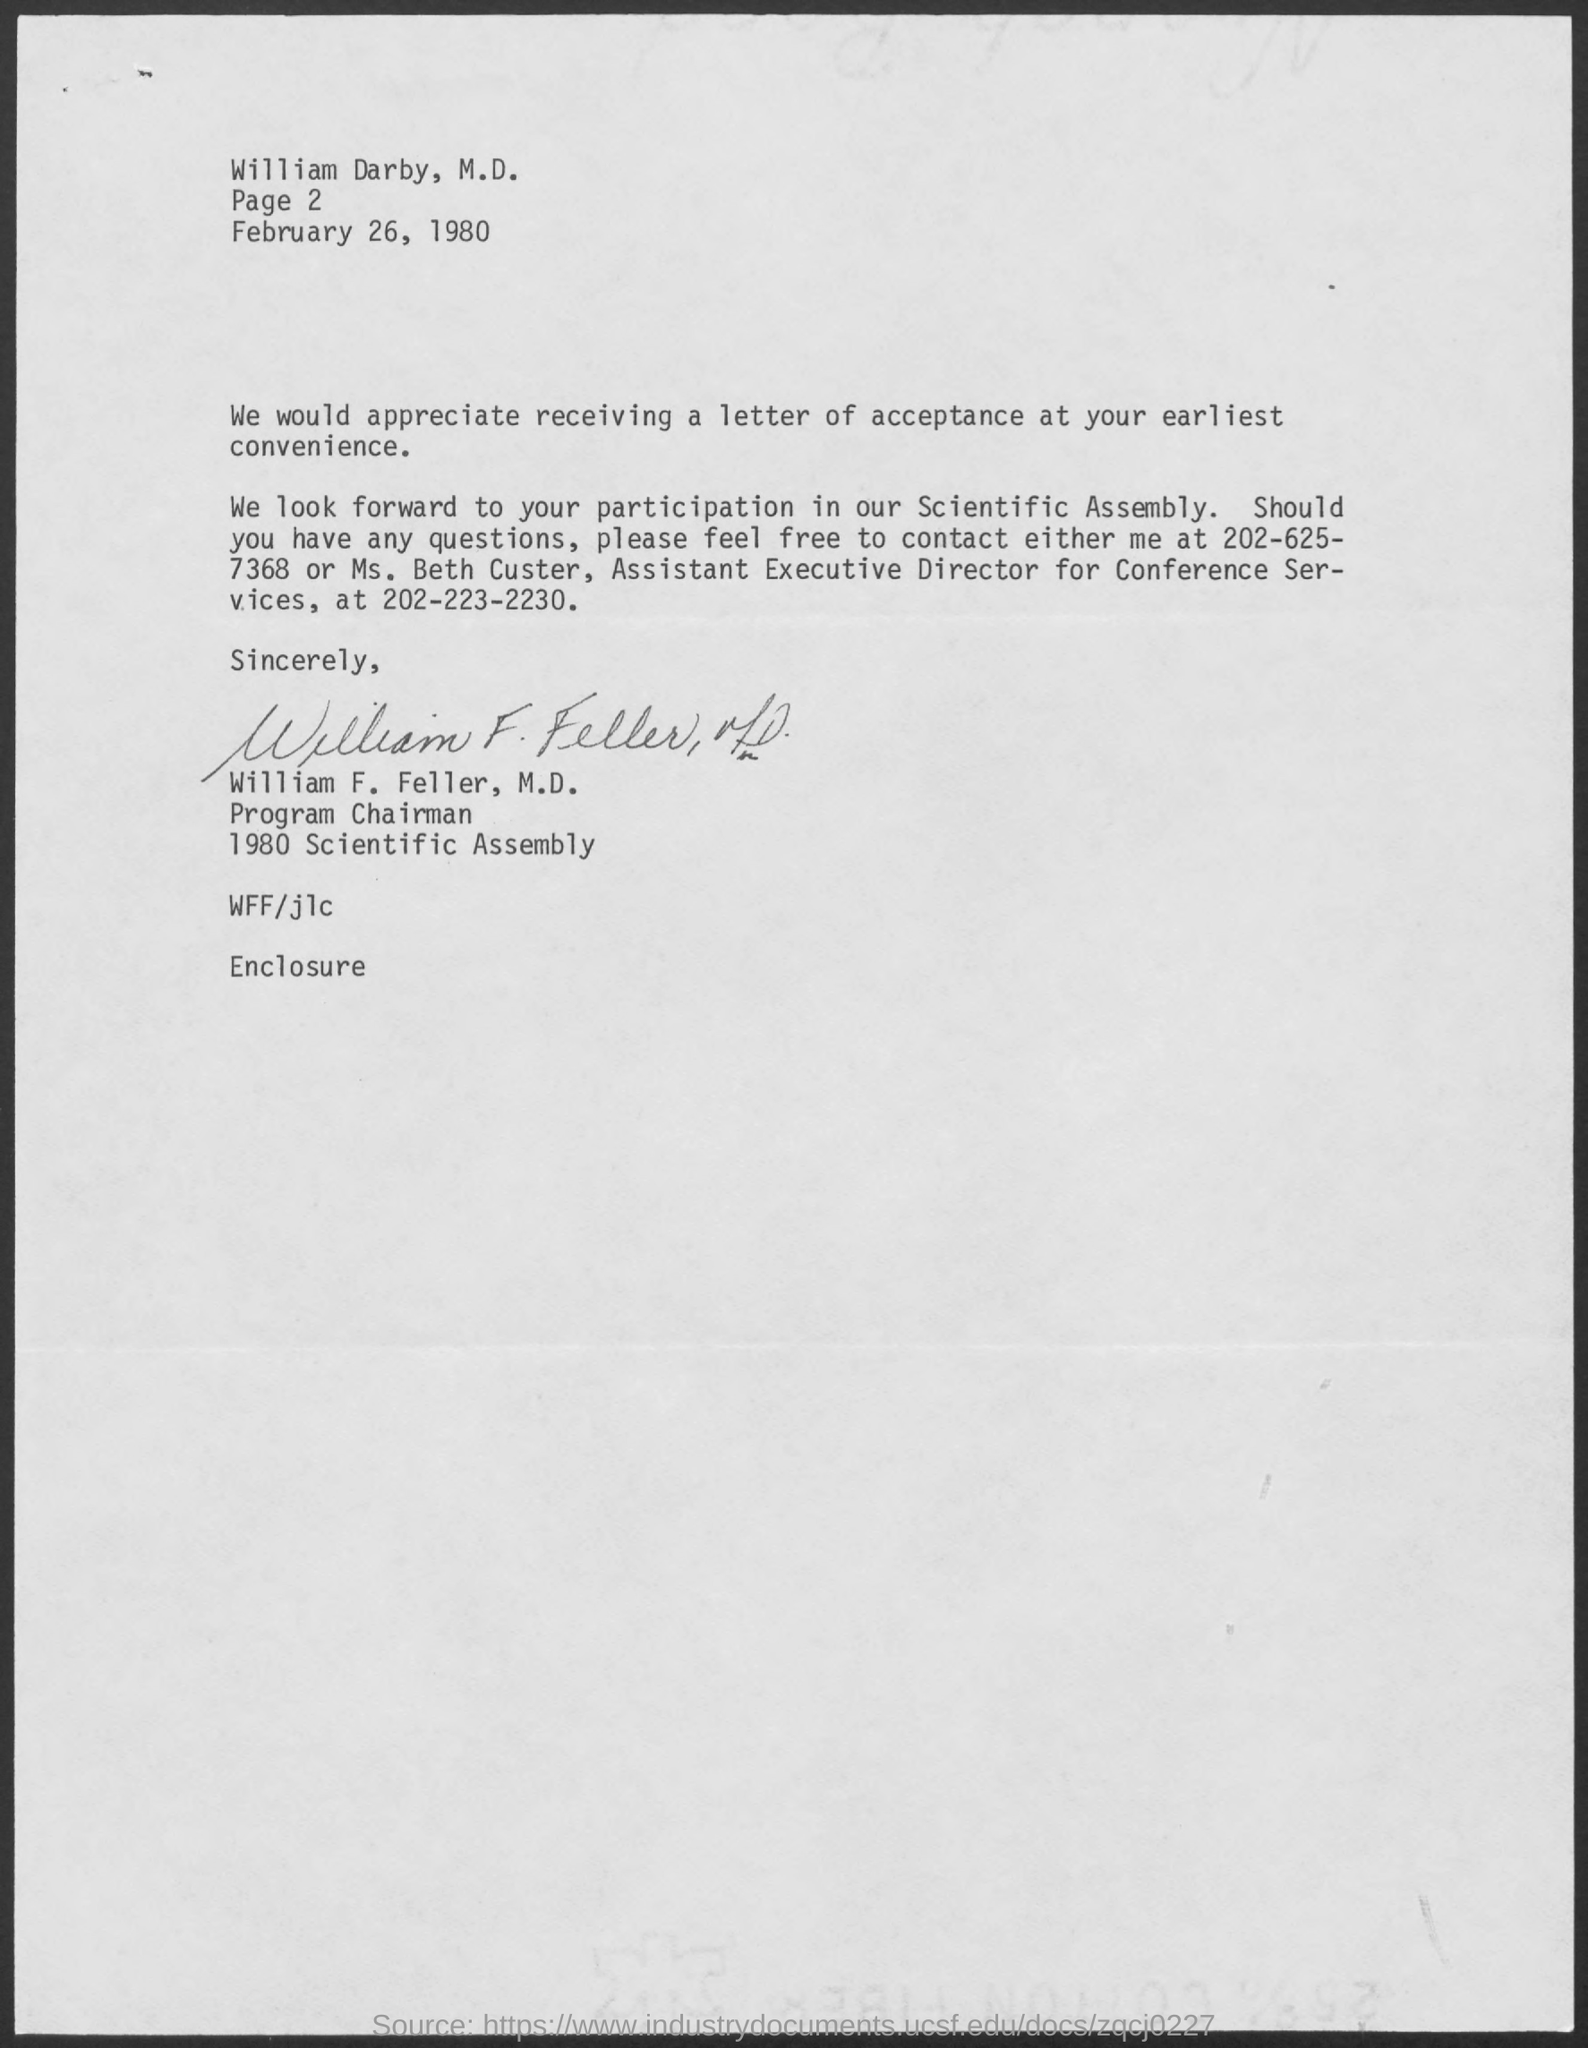What is the page no mentioned in this letter?
Make the answer very short. 2. What is the contact no of Ms. Beth Custer as given in the letter?
Ensure brevity in your answer.  202-223-2230. 